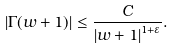Convert formula to latex. <formula><loc_0><loc_0><loc_500><loc_500>\left | \Gamma ( w + 1 ) \right | \leq \frac { C } { \left | w + 1 \right | ^ { 1 + \varepsilon } } .</formula> 